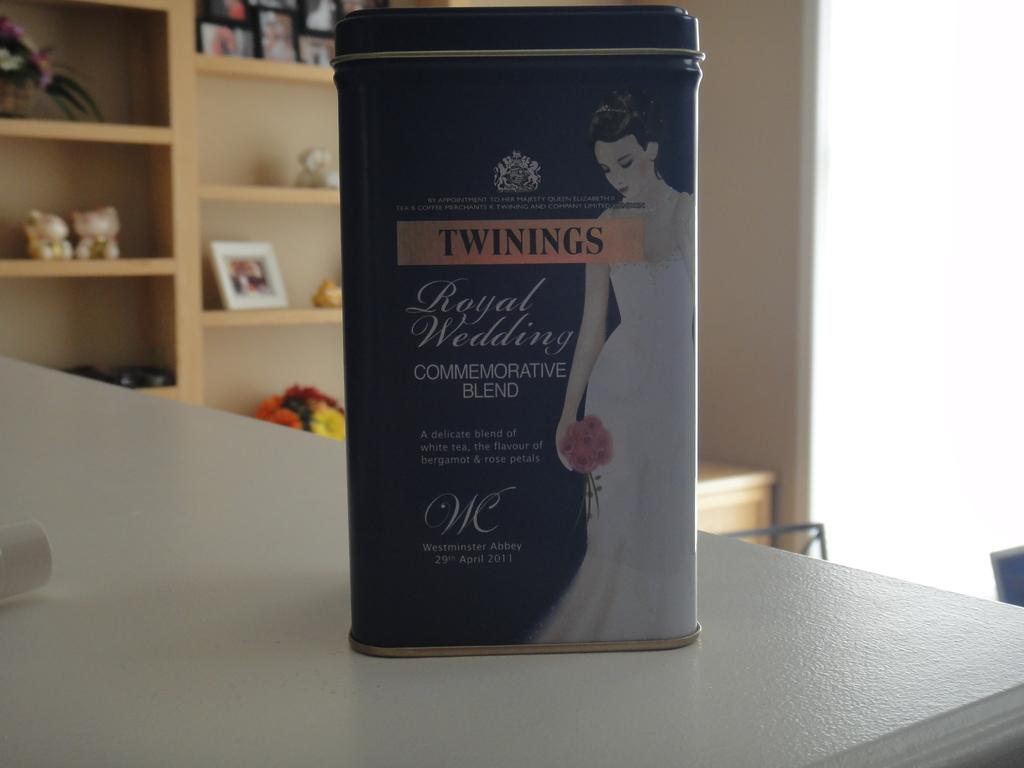<image>
Render a clear and concise summary of the photo. A box of Twinings is a royal wedding commemorative blend. 